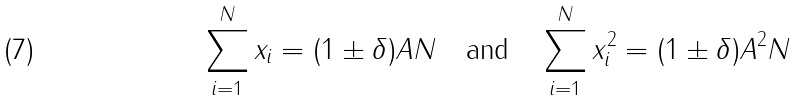Convert formula to latex. <formula><loc_0><loc_0><loc_500><loc_500>\sum _ { i = 1 } ^ { N } x _ { i } = ( 1 \pm \delta ) A N \text {\quad and\quad } \sum _ { i = 1 } ^ { N } x _ { i } ^ { 2 } = ( 1 \pm \delta ) A ^ { 2 } N</formula> 